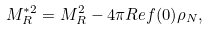Convert formula to latex. <formula><loc_0><loc_0><loc_500><loc_500>M _ { R } ^ { * 2 } = M ^ { 2 } _ { R } - 4 \pi R e { f ( 0 ) } \rho _ { N } ,</formula> 